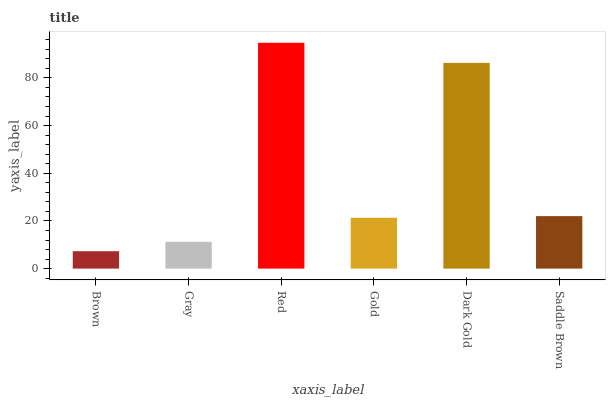Is Brown the minimum?
Answer yes or no. Yes. Is Red the maximum?
Answer yes or no. Yes. Is Gray the minimum?
Answer yes or no. No. Is Gray the maximum?
Answer yes or no. No. Is Gray greater than Brown?
Answer yes or no. Yes. Is Brown less than Gray?
Answer yes or no. Yes. Is Brown greater than Gray?
Answer yes or no. No. Is Gray less than Brown?
Answer yes or no. No. Is Saddle Brown the high median?
Answer yes or no. Yes. Is Gold the low median?
Answer yes or no. Yes. Is Gold the high median?
Answer yes or no. No. Is Gray the low median?
Answer yes or no. No. 